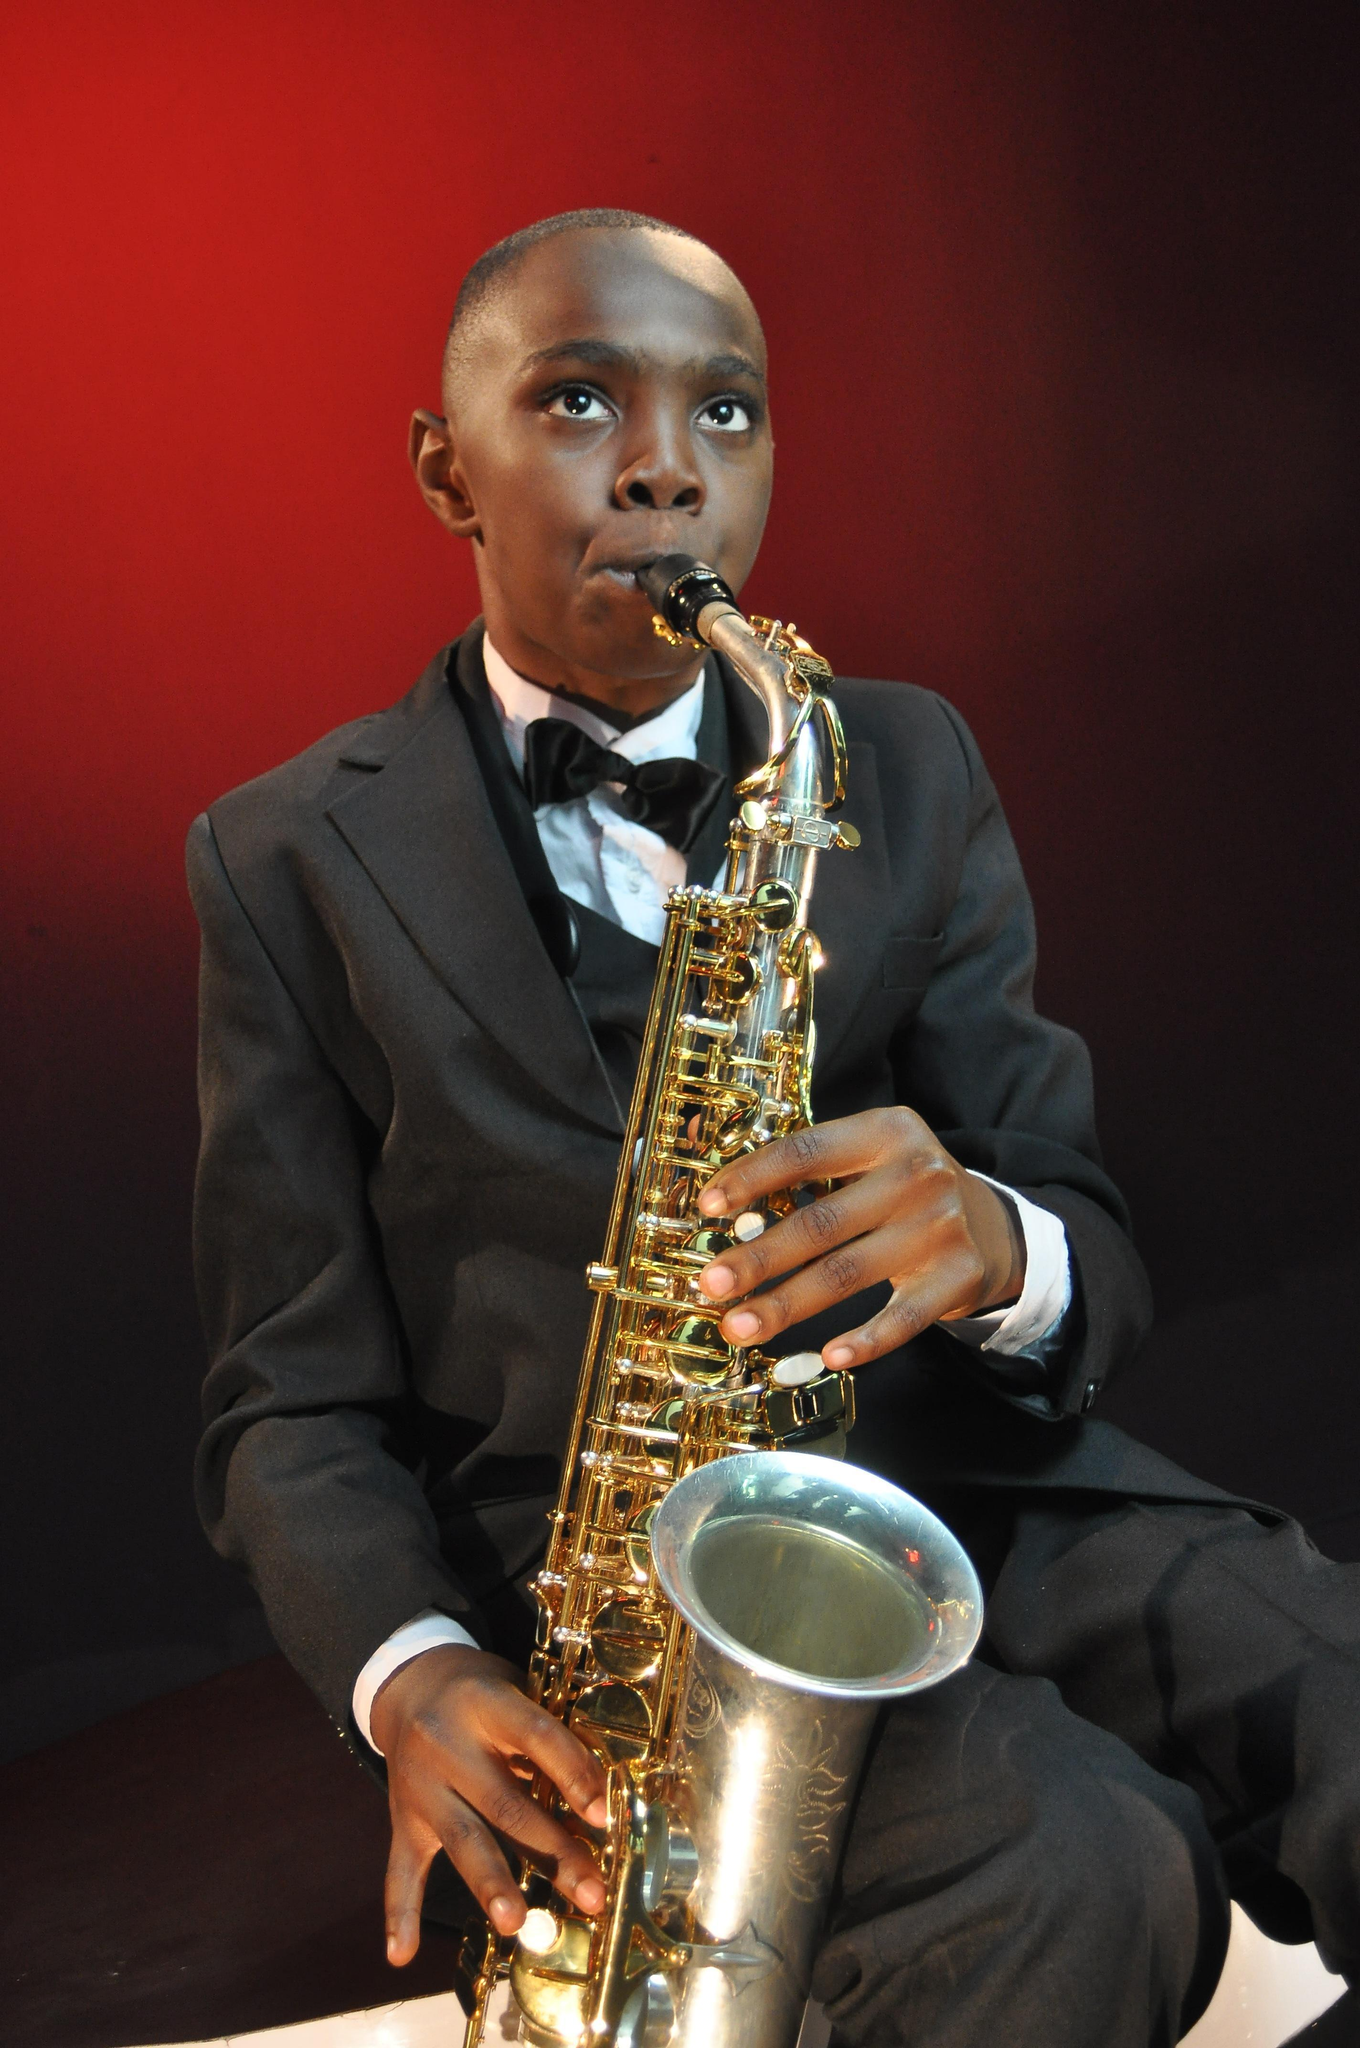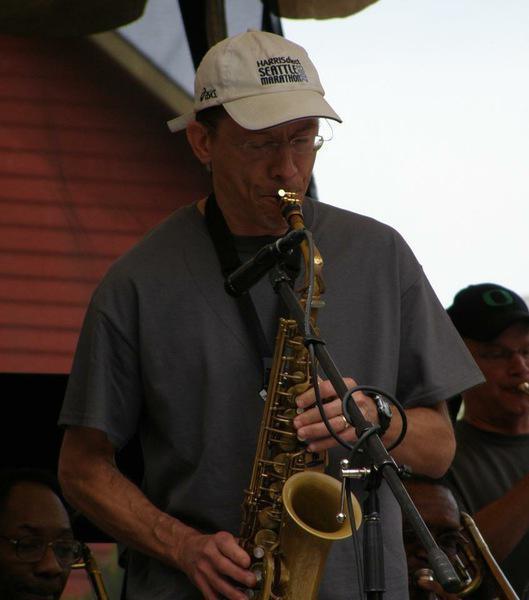The first image is the image on the left, the second image is the image on the right. Given the left and right images, does the statement "A white man is playing a saxophone in the image on the right." hold true? Answer yes or no. Yes. The first image is the image on the left, the second image is the image on the right. Considering the images on both sides, is "An image shows an adult black male with shaved head, playing the saxophone while dressed all in black." valid? Answer yes or no. No. 